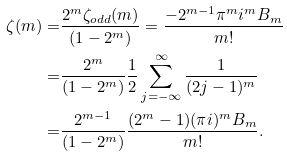<formula> <loc_0><loc_0><loc_500><loc_500>\zeta ( m ) = & \frac { 2 ^ { m } \zeta _ { o d d } ( m ) } { ( 1 - 2 ^ { m } ) } = \frac { - 2 ^ { m - 1 } \pi ^ { m } i ^ { m } B _ { m } } { m ! } \\ = & \frac { 2 ^ { m } } { ( 1 - 2 ^ { m } ) } \frac { 1 } { 2 } \sum _ { j = - \infty } ^ { \infty } \frac { 1 } { ( 2 j - 1 ) ^ { m } } \\ = & \frac { 2 ^ { m - 1 } } { ( 1 - 2 ^ { m } ) } \frac { ( 2 ^ { m } - 1 ) ( \pi i ) ^ { m } B _ { m } } { m ! } .</formula> 